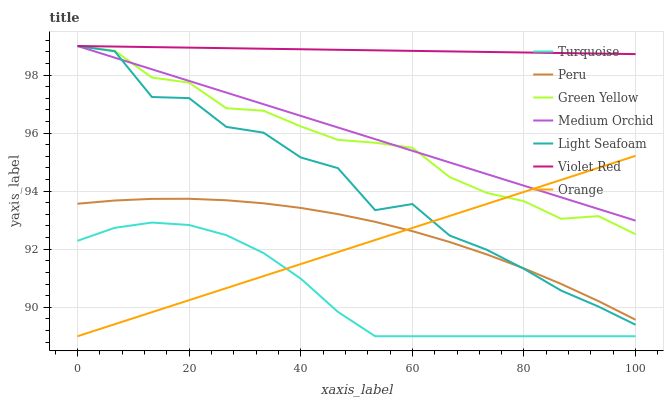Does Turquoise have the minimum area under the curve?
Answer yes or no. Yes. Does Violet Red have the maximum area under the curve?
Answer yes or no. Yes. Does Green Yellow have the minimum area under the curve?
Answer yes or no. No. Does Green Yellow have the maximum area under the curve?
Answer yes or no. No. Is Medium Orchid the smoothest?
Answer yes or no. Yes. Is Light Seafoam the roughest?
Answer yes or no. Yes. Is Green Yellow the smoothest?
Answer yes or no. No. Is Green Yellow the roughest?
Answer yes or no. No. Does Green Yellow have the lowest value?
Answer yes or no. No. Does Peru have the highest value?
Answer yes or no. No. Is Turquoise less than Peru?
Answer yes or no. Yes. Is Peru greater than Turquoise?
Answer yes or no. Yes. Does Turquoise intersect Peru?
Answer yes or no. No. 